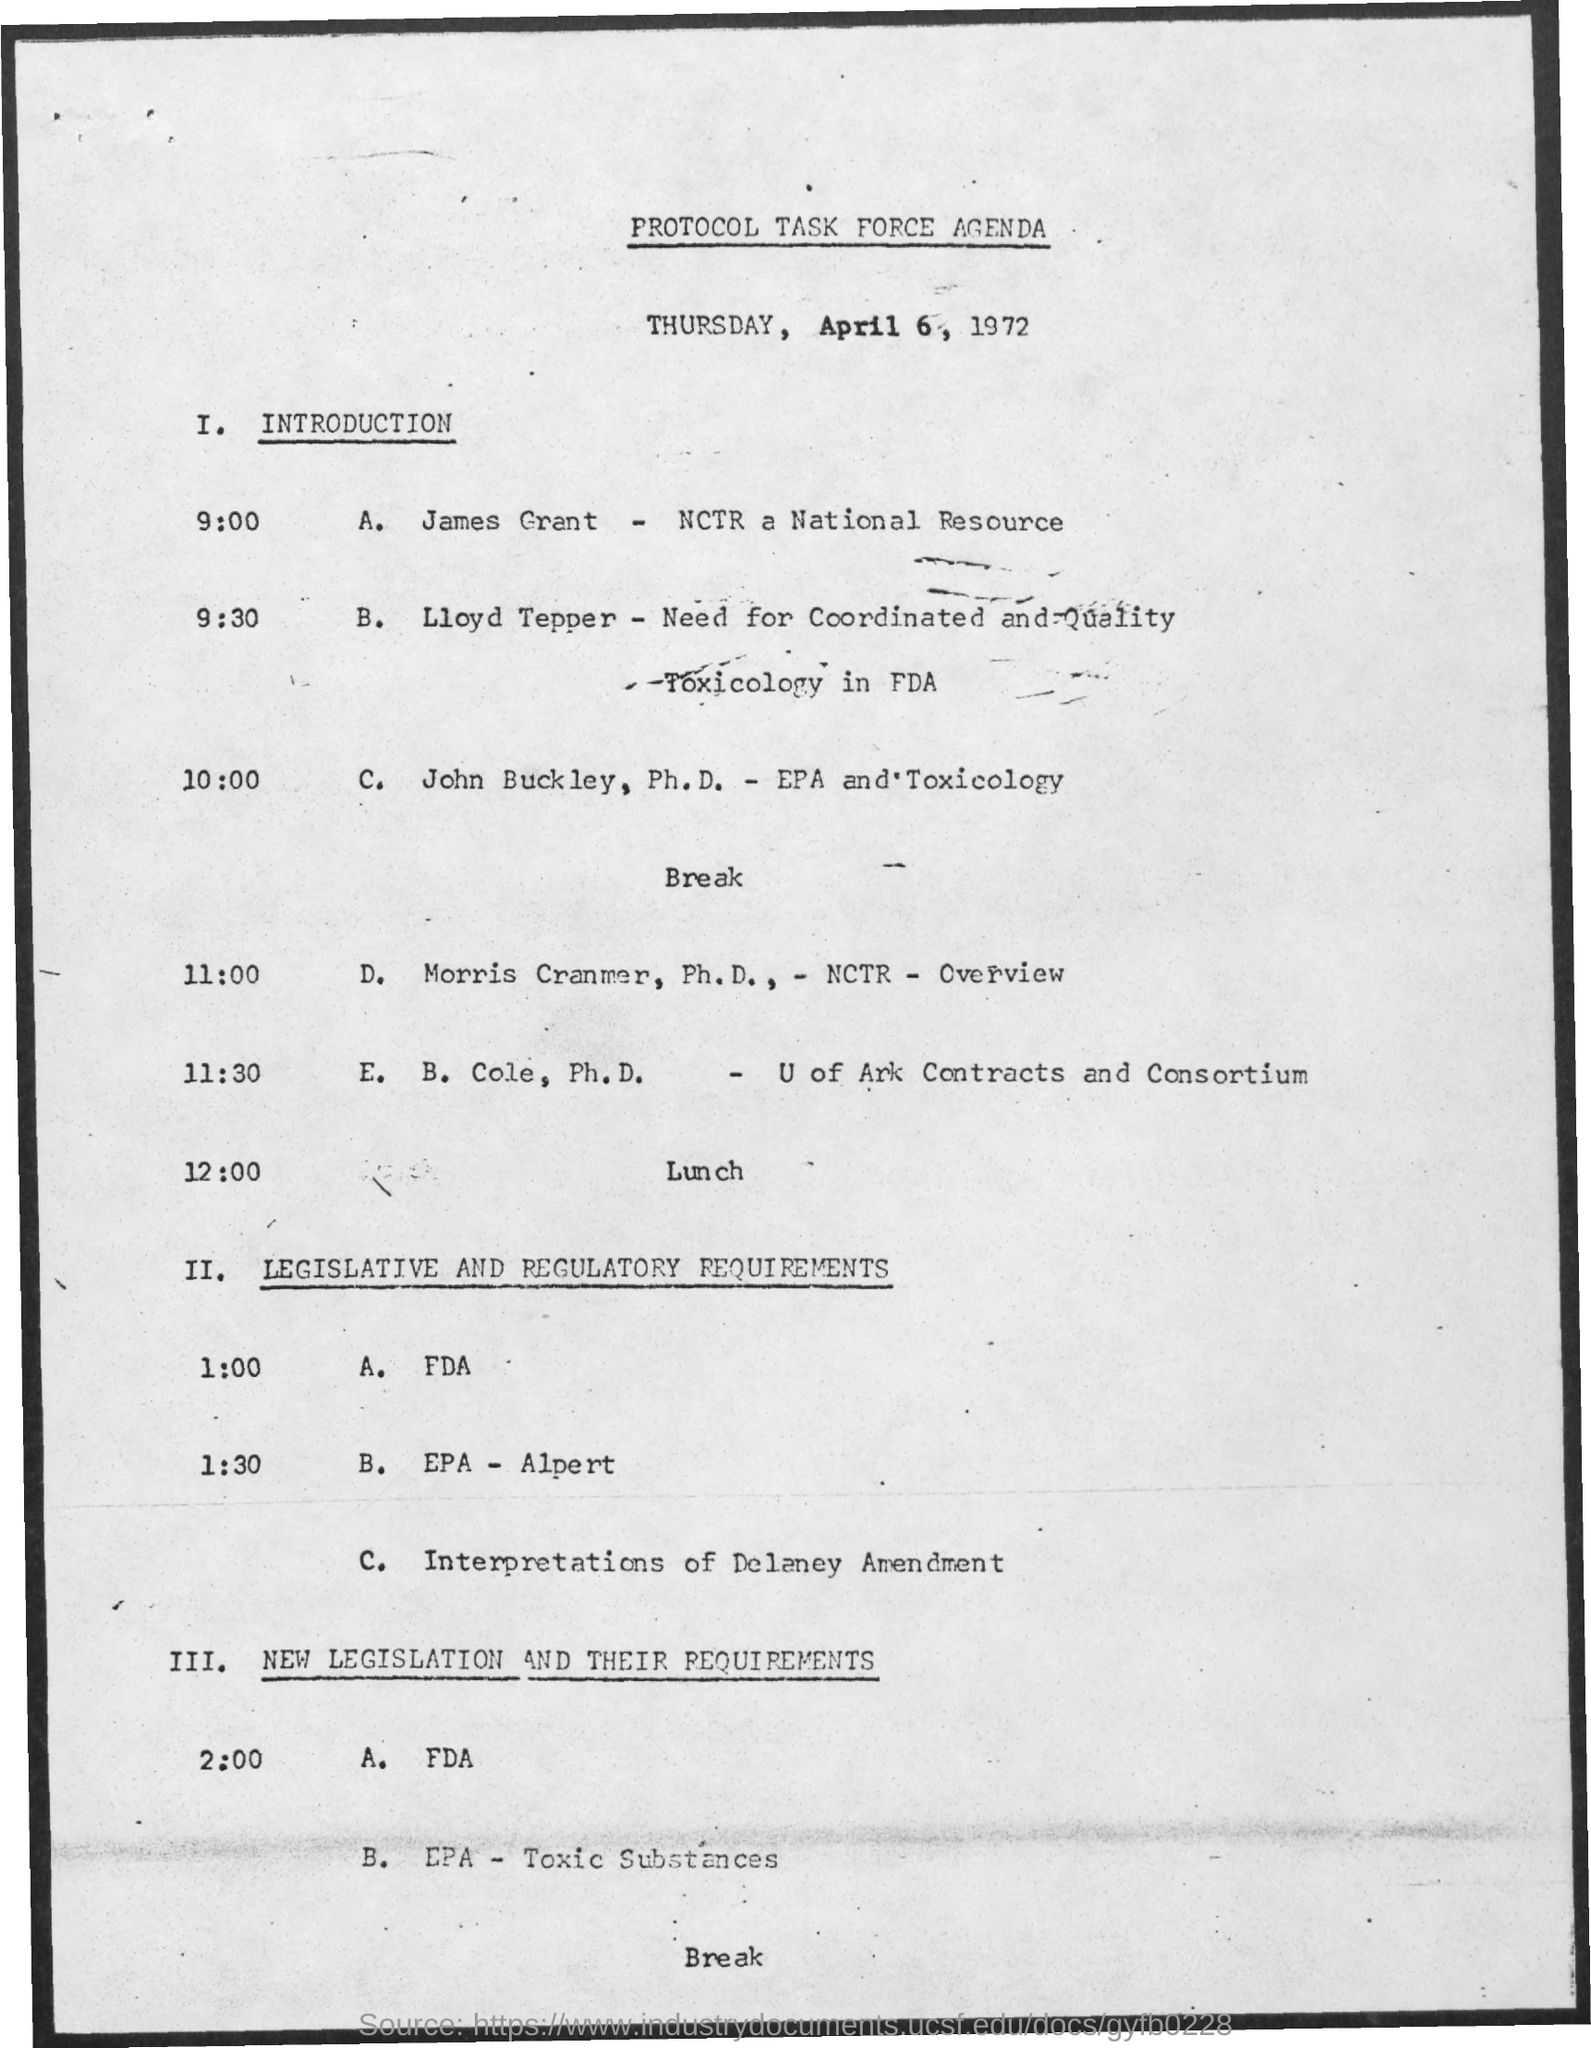Indicate a few pertinent items in this graphic. The title of the document is the protocol task force agenda. John Buckley holds a Ph.D. in Environmental Protection Agency (EPA) and Toxicology. 